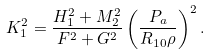Convert formula to latex. <formula><loc_0><loc_0><loc_500><loc_500>K _ { 1 } ^ { 2 } = \frac { H _ { 1 } ^ { 2 } + M _ { 2 } ^ { 2 } } { F ^ { 2 } + G ^ { 2 } } \left ( { \frac { P _ { a } } { { R _ { 1 0 } \rho } } } \right ) ^ { 2 } .</formula> 